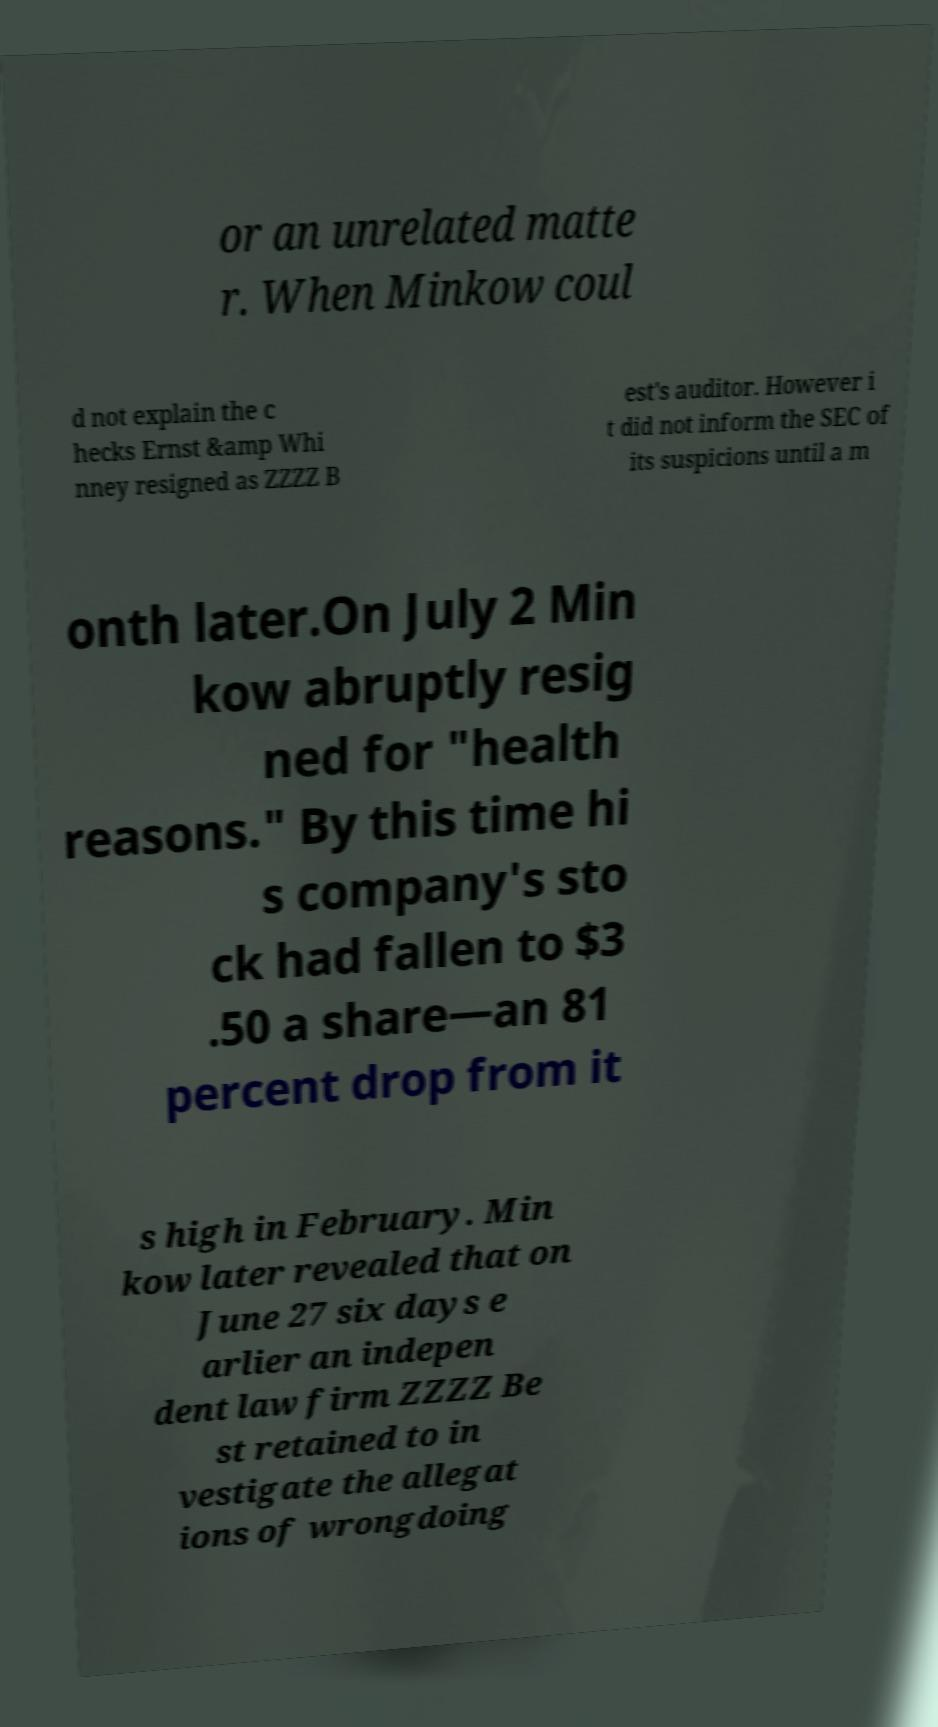Can you accurately transcribe the text from the provided image for me? or an unrelated matte r. When Minkow coul d not explain the c hecks Ernst &amp Whi nney resigned as ZZZZ B est's auditor. However i t did not inform the SEC of its suspicions until a m onth later.On July 2 Min kow abruptly resig ned for "health reasons." By this time hi s company's sto ck had fallen to $3 .50 a share—an 81 percent drop from it s high in February. Min kow later revealed that on June 27 six days e arlier an indepen dent law firm ZZZZ Be st retained to in vestigate the allegat ions of wrongdoing 